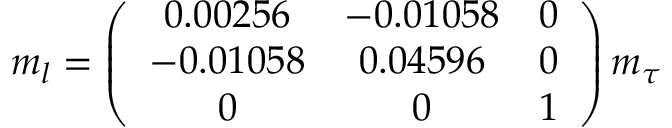<formula> <loc_0><loc_0><loc_500><loc_500>m _ { l } = \left ( \begin{array} { c c c } { 0 . 0 0 2 5 6 } & { - 0 . 0 1 0 5 8 } & { 0 } \\ { - 0 . 0 1 0 5 8 } & { 0 . 0 4 5 9 6 } & { 0 } \\ { 0 } & { 0 } & { 1 } \end{array} \right ) m _ { \tau }</formula> 